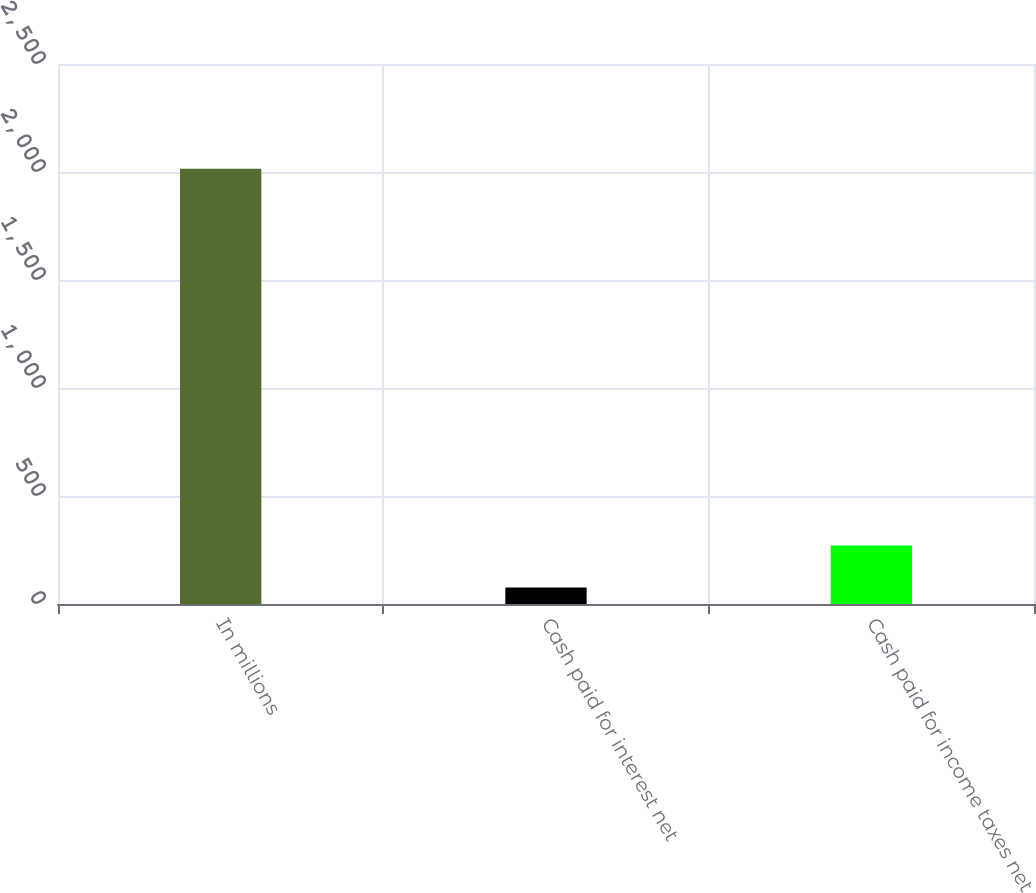Convert chart to OTSL. <chart><loc_0><loc_0><loc_500><loc_500><bar_chart><fcel>In millions<fcel>Cash paid for interest net<fcel>Cash paid for income taxes net<nl><fcel>2015<fcel>76.9<fcel>270.71<nl></chart> 